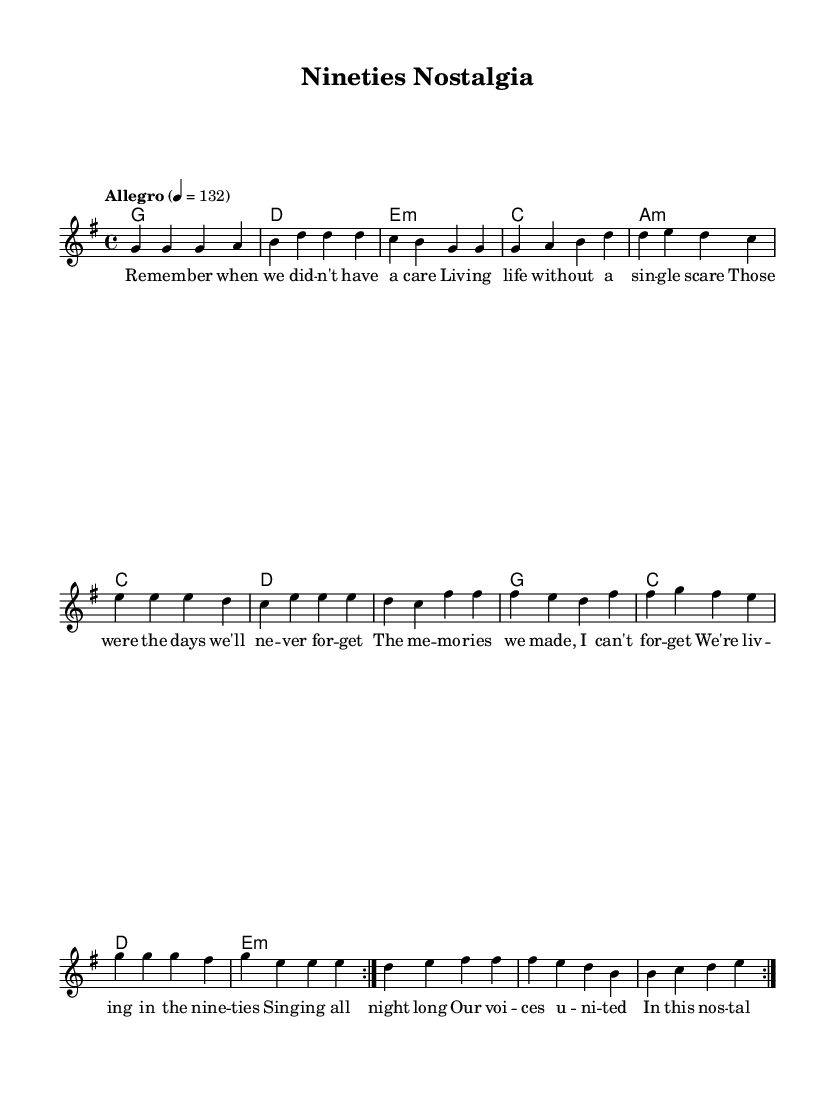What is the key signature of this music? The key signature is G major, which has one sharp (F#).
Answer: G major What is the time signature of this music? The time signature is 4/4, meaning there are four beats per measure.
Answer: 4/4 What is the tempo marking for this piece? The tempo marking is "Allegro," indicating a fast, lively speed.
Answer: Allegro How many measures are there in the melody? The melody is structured to repeat two times; counting all measures results in 16 measures total.
Answer: 16 What type of chords are predominantly used in this piece? The piece mainly uses major and minor chords, which are typical in pop-rock music.
Answer: Major and minor Which line in the lyrics emphasizes nostalgia in the song? The line "Those were the days we'll ne -- ver for -- get" expresses strong nostalgia and memories.
Answer: Those were the days we'll ne -- ver for -- get How does the structure of the lyrics contribute to sing-alongs? The lyrics have a repetitive structure and catchy phrases, which invite audiences to sing along easily.
Answer: Repetitive structure 